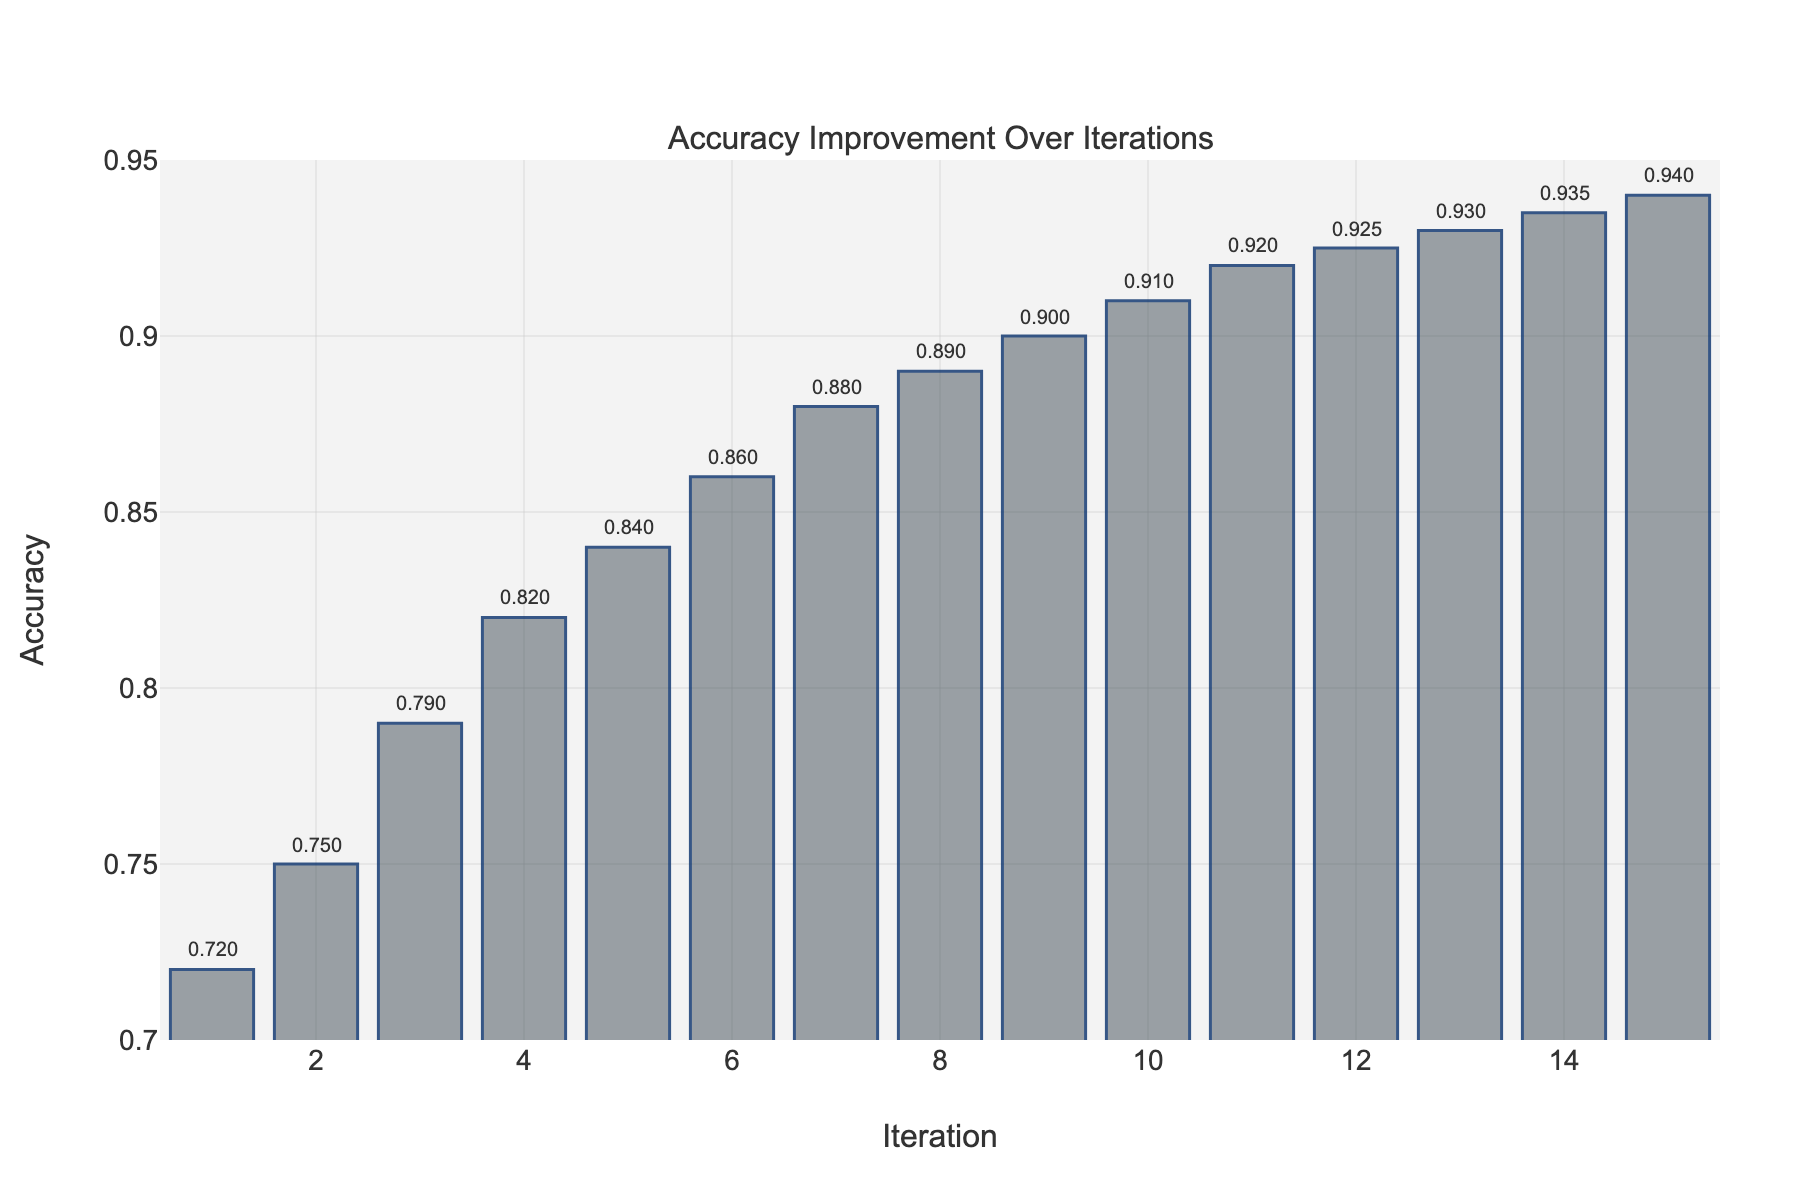What is the accuracy at iteration 10? Look for the bar corresponding to iteration 10 and read the value indicated at the top of the bar, which is 0.91.
Answer: 0.91 By how much did the accuracy improve from iteration 1 to iteration 5? Subtract the accuracy at iteration 1 (0.72) from the accuracy at iteration 5 (0.84): 0.84 - 0.72 = 0.12.
Answer: 0.12 Which iteration had the highest accuracy? Check the values at the top of all the bars and find the maximum value, which is at iteration 15 with an accuracy of 0.94.
Answer: Iteration 15 Compare the accuracy improvement between iterations 5 and 10 with that between iterations 10 and 15. Which period saw a larger improvement? Calculate the accuracy improvement between iterations 5 and 10: 0.91 - 0.84 = 0.07. Then, calculate between iterations 10 and 15: 0.94 - 0.91 = 0.03. The first period (0.07) saw larger improvement than the second (0.03).
Answer: Iterations 5-10 What's the average accuracy over the first five iterations? Sum the accuracy values for iterations 1 to 5: 0.72 + 0.75 + 0.79 + 0.82 + 0.84 = 3.92. Then divide by 5 to get the average: 3.92 / 5 = 0.784.
Answer: 0.784 Is there any iteration where the accuracy did not improve compared to the previous iteration? Check each iteration and compare its accuracy value with the previous one. All iterations show a steady improvement with each subsequent iteration.
Answer: No What was the smallest improvement in accuracy recorded between two consecutive iterations? Compare the accuracy differences between all consecutive iterations. The smallest improvement is between iteration 11 (0.92) and iteration 12 (0.925), which is 0.005.
Answer: 0.005 How many iterations achieved an accuracy of 0.9 or higher? Look at the bars and count those with accuracy values of 0.9 or higher, which are iterations 9 through 15. This gives us 7 iterations.
Answer: 7 By how much did the accuracy improve on average per iteration from iteration 1 to iteration 15? The total improvement is the difference between iteration 1 and iteration 15: 0.94 - 0.72 = 0.22. Divide this by the number of iterations minus one (to average over the intervals): 0.22 / 14 ≈ 0.0157.
Answer: 0.0157 